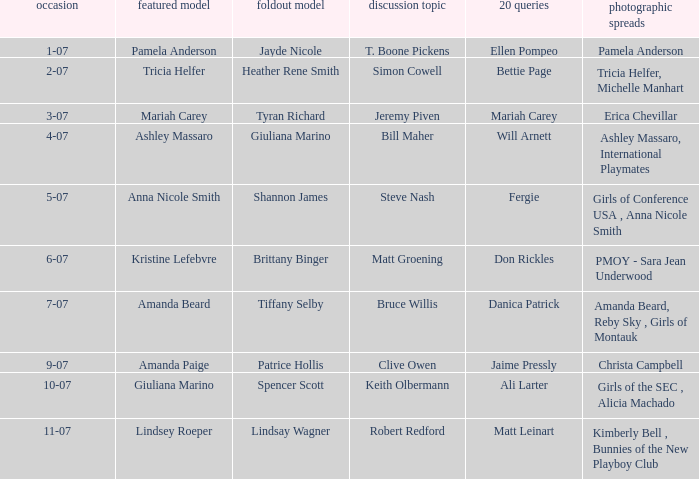List the pictorals from issues when lindsey roeper was the cover model. Kimberly Bell , Bunnies of the New Playboy Club. 